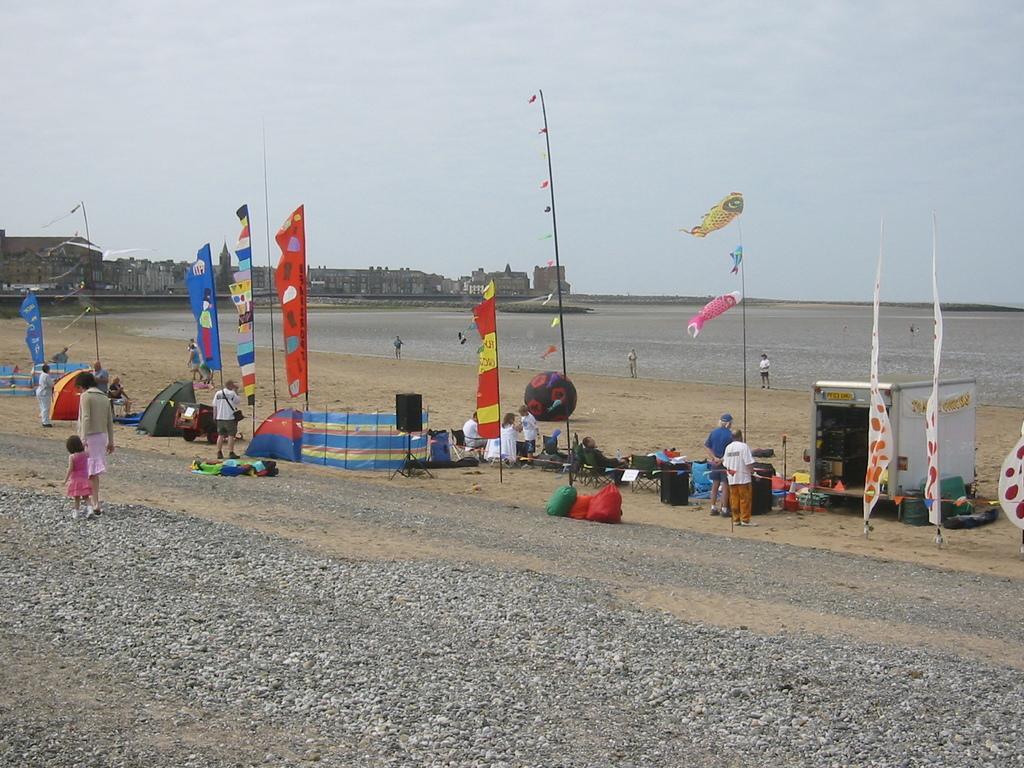How would you summarize this image in a sentence or two? In this picture we can see a beach, we can see few people, around we can see some flags and tents, we can see some buildings. 